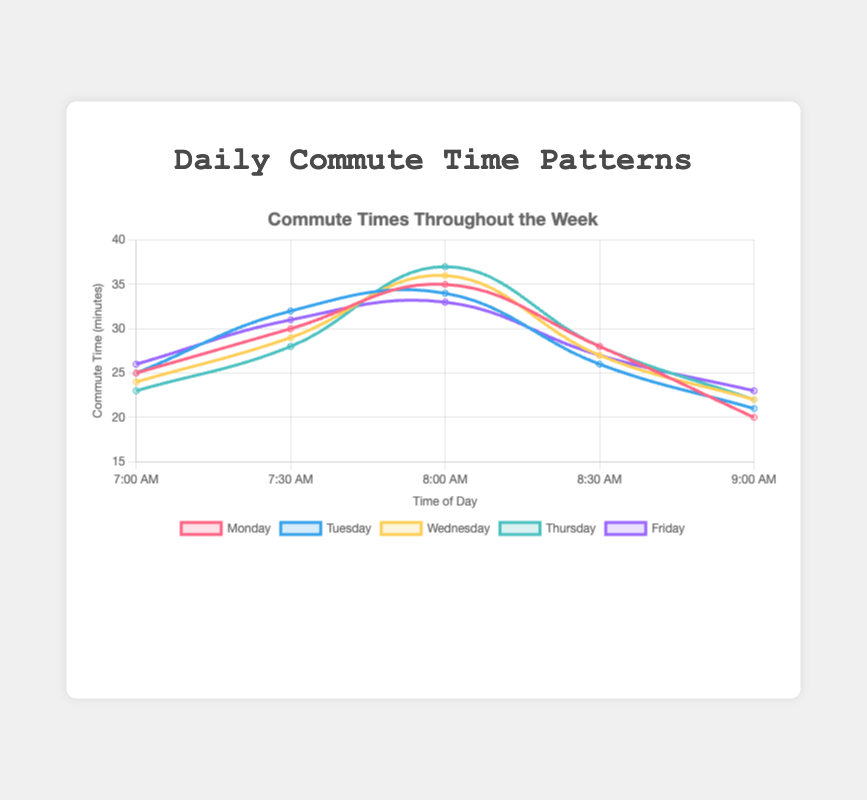What is the peak commute time for Monday? To find the peak commute time on Monday, look at the curve labeled "Monday" and identify the highest point on the y-axis. The peak commute time, represented by the highest value, is 35 minutes at 8:00 AM.
Answer: 8:00 AM On which day is the earliest commute time the longest? Compare the commute times at 7:00 AM across all days. Monday, Tuesday, and Friday have 25-26 minutes, Wednesday has 24 minutes, and Thursday has 23 minutes. Thus, Friday has the longest commute time at 7:00 AM with 26 minutes.
Answer: Friday By how many minutes does the commute time decrease from 8:00 AM to 9:00 AM on Thursday? Locate the commute times for Thursday at 8:00 AM (37 minutes) and 9:00 AM (22 minutes). Subtract the 9:00 AM time from the 8:00 AM time: 37 - 22 = 15 minutes.
Answer: 15 minutes 